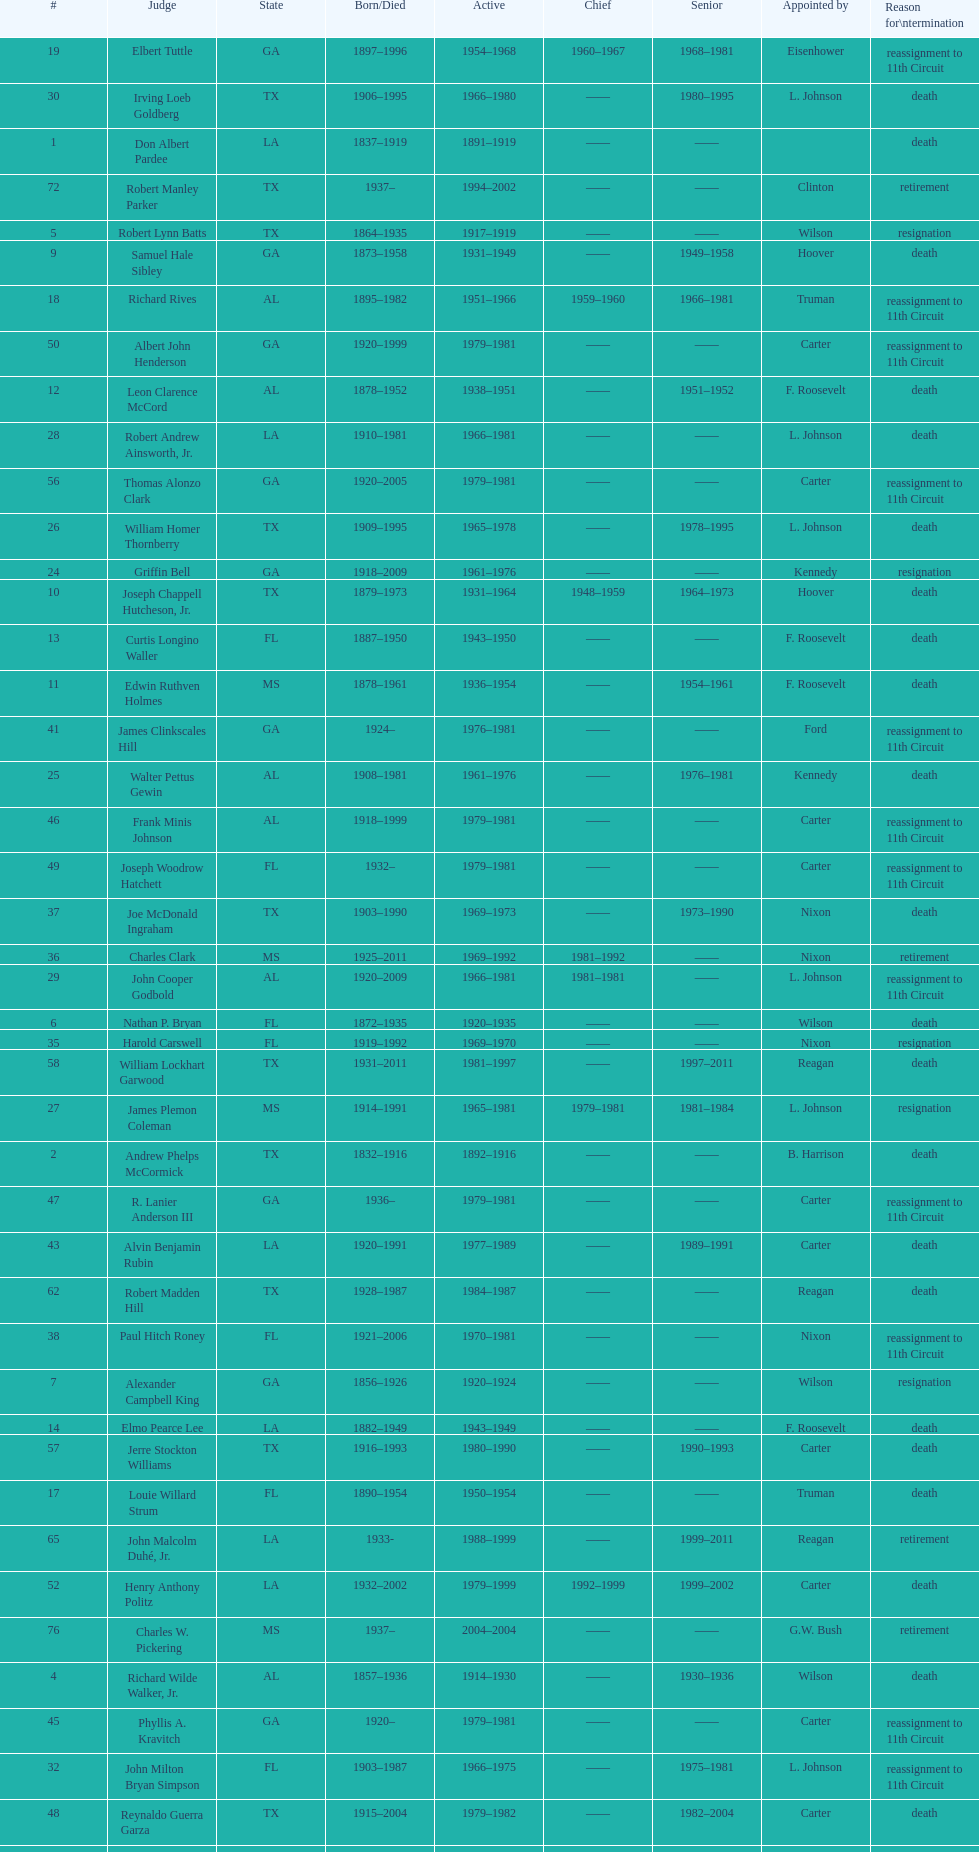Who was the first judge appointed from georgia? Alexander Campbell King. 